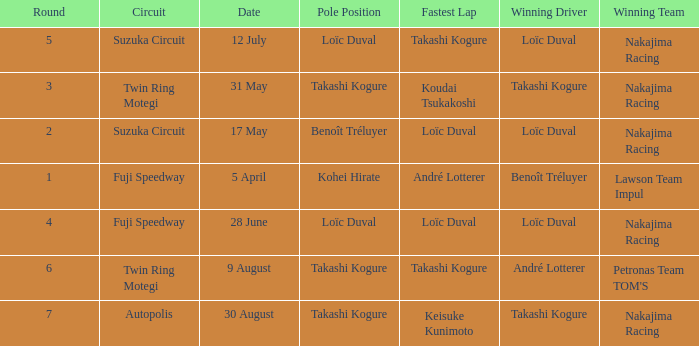What was the earlier round where Takashi Kogure got the fastest lap? 5.0. 